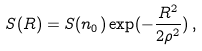Convert formula to latex. <formula><loc_0><loc_0><loc_500><loc_500>S ( R ) = S ( n _ { 0 } ) \exp ( - \frac { R ^ { 2 } } { 2 \rho ^ { 2 } } ) \, ,</formula> 